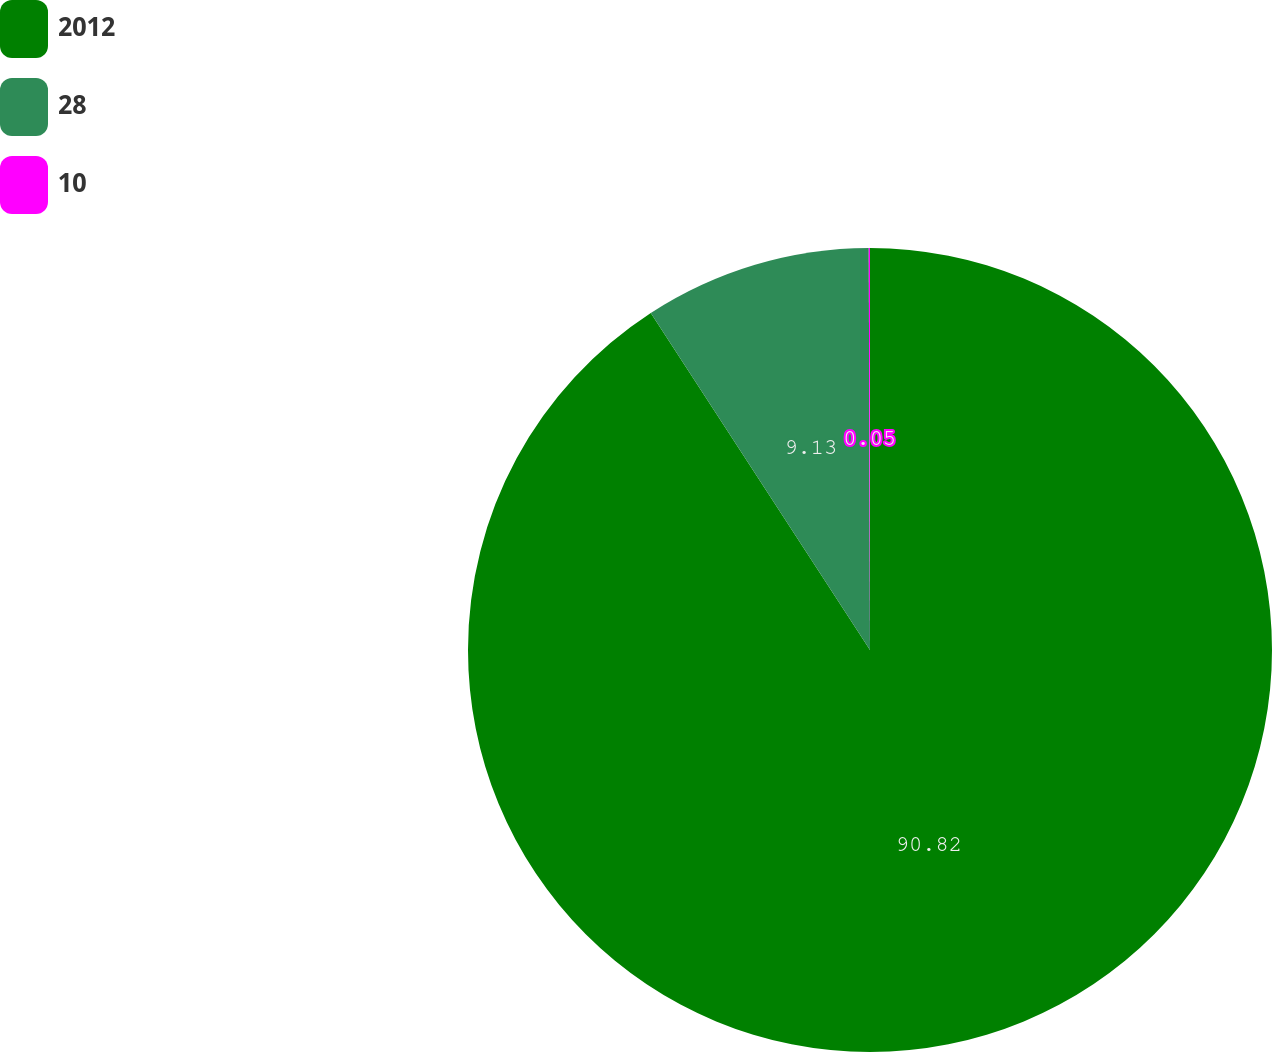Convert chart to OTSL. <chart><loc_0><loc_0><loc_500><loc_500><pie_chart><fcel>2012<fcel>28<fcel>10<nl><fcel>90.82%<fcel>9.13%<fcel>0.05%<nl></chart> 